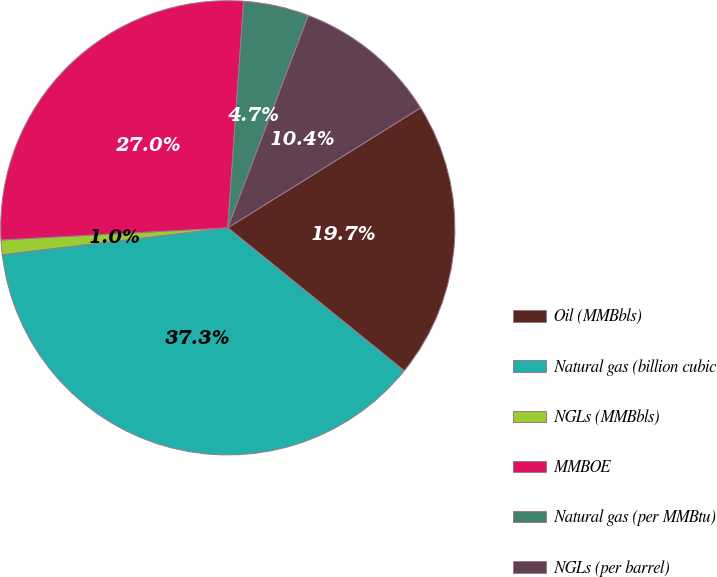Convert chart. <chart><loc_0><loc_0><loc_500><loc_500><pie_chart><fcel>Oil (MMBbls)<fcel>Natural gas (billion cubic<fcel>NGLs (MMBbls)<fcel>MMBOE<fcel>Natural gas (per MMBtu)<fcel>NGLs (per barrel)<nl><fcel>19.7%<fcel>37.28%<fcel>1.03%<fcel>26.97%<fcel>4.66%<fcel>10.37%<nl></chart> 